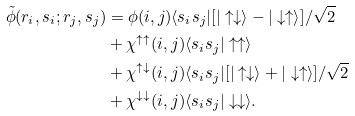Convert formula to latex. <formula><loc_0><loc_0><loc_500><loc_500>\tilde { \phi } ( { r } _ { i } , s _ { i } ; { r } _ { j } , s _ { j } ) & = \phi ( i , j ) \langle s _ { i } s _ { j } | [ | \uparrow \downarrow \rangle - | \downarrow \uparrow \rangle ] / \sqrt { 2 } \\ & + \chi ^ { \uparrow \uparrow } ( i , j ) \langle s _ { i } s _ { j } | \uparrow \uparrow \rangle \\ & + \chi ^ { \uparrow \downarrow } ( i , j ) \langle s _ { i } s _ { j } | [ | \uparrow \downarrow \rangle + | \downarrow \uparrow \rangle ] / \sqrt { 2 } \\ & + \chi ^ { \downarrow \downarrow } ( i , j ) \langle s _ { i } s _ { j } | \downarrow \downarrow \rangle .</formula> 